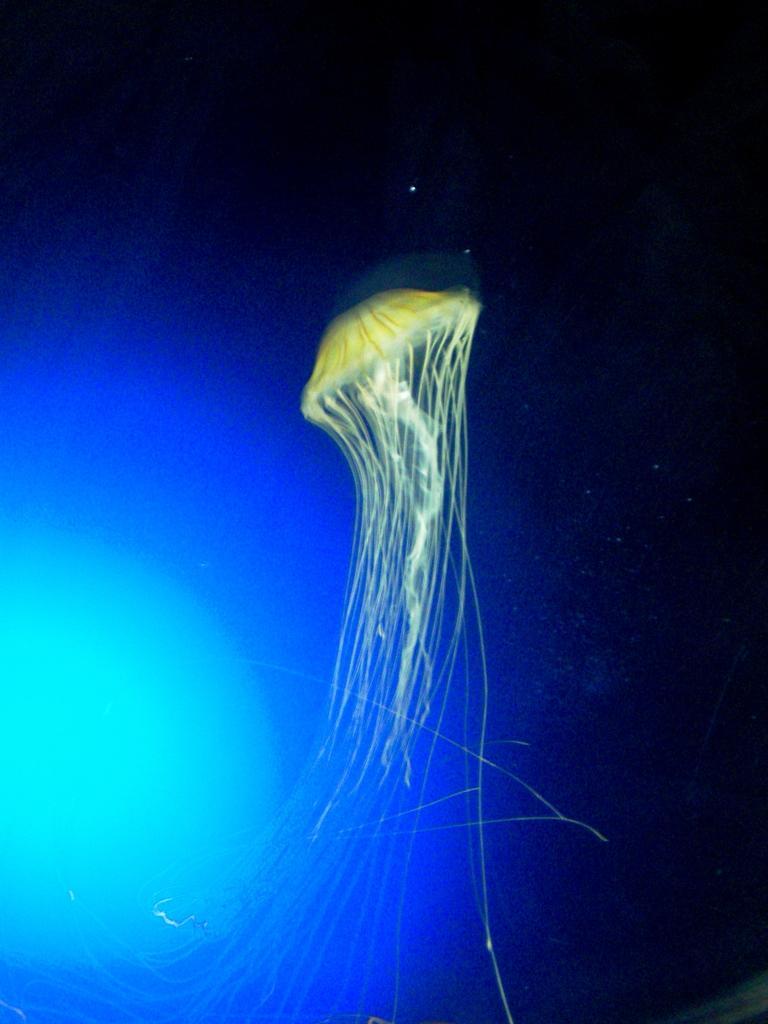Please provide a concise description of this image. In this picture I can observe jellyfish which is in green color. On the left side I can observe blue color light. The background is dark. 